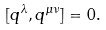Convert formula to latex. <formula><loc_0><loc_0><loc_500><loc_500>[ q ^ { \lambda } , q ^ { \mu \nu } ] = 0 .</formula> 